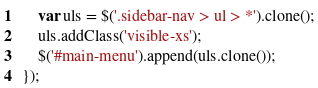<code> <loc_0><loc_0><loc_500><loc_500><_JavaScript_>	var uls = $('.sidebar-nav > ul > *').clone();
	uls.addClass('visible-xs');
	$('#main-menu').append(uls.clone());
});</code> 